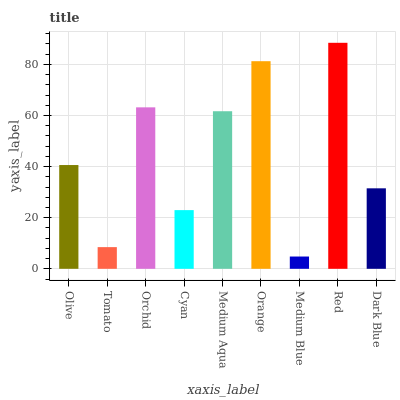Is Medium Blue the minimum?
Answer yes or no. Yes. Is Red the maximum?
Answer yes or no. Yes. Is Tomato the minimum?
Answer yes or no. No. Is Tomato the maximum?
Answer yes or no. No. Is Olive greater than Tomato?
Answer yes or no. Yes. Is Tomato less than Olive?
Answer yes or no. Yes. Is Tomato greater than Olive?
Answer yes or no. No. Is Olive less than Tomato?
Answer yes or no. No. Is Olive the high median?
Answer yes or no. Yes. Is Olive the low median?
Answer yes or no. Yes. Is Orange the high median?
Answer yes or no. No. Is Dark Blue the low median?
Answer yes or no. No. 